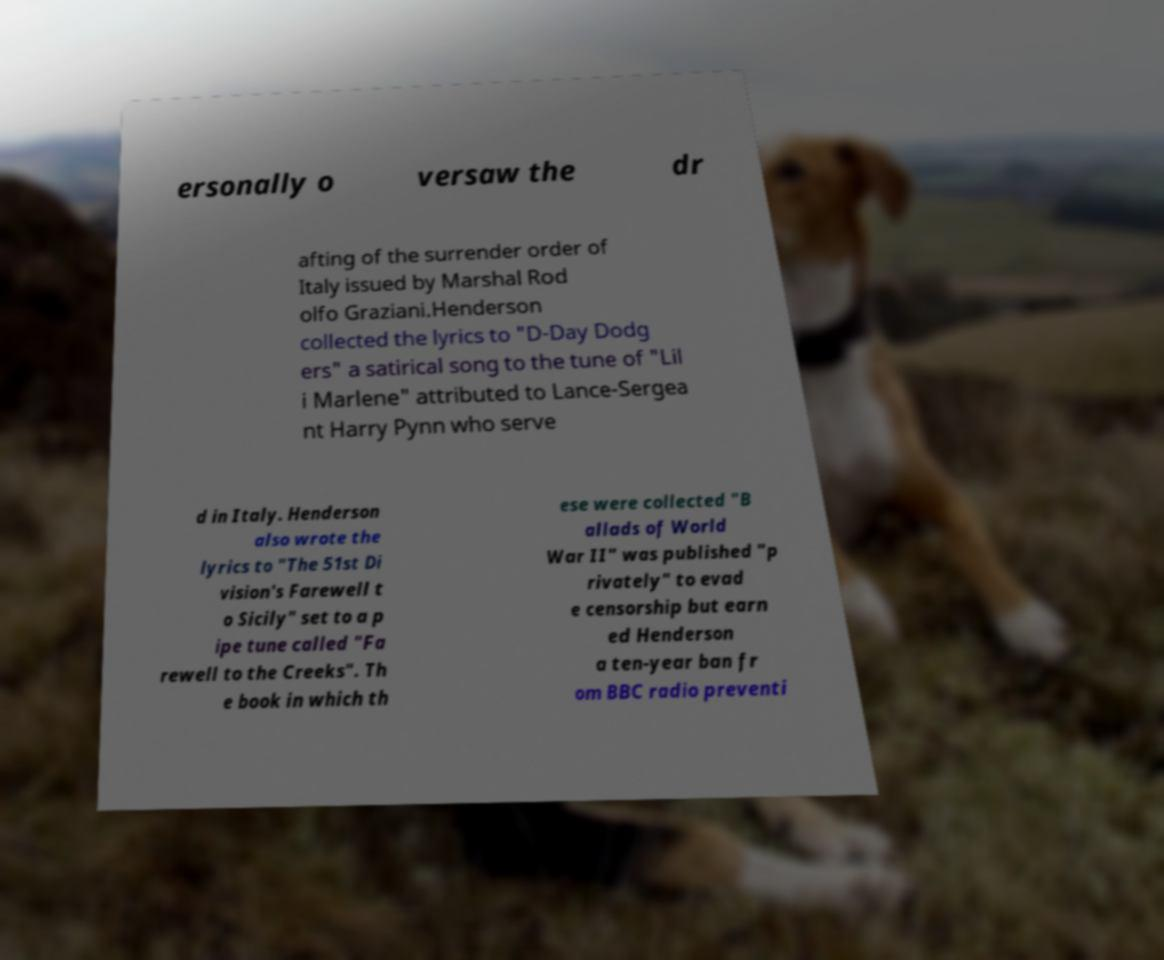Could you assist in decoding the text presented in this image and type it out clearly? ersonally o versaw the dr afting of the surrender order of Italy issued by Marshal Rod olfo Graziani.Henderson collected the lyrics to "D-Day Dodg ers" a satirical song to the tune of "Lil i Marlene" attributed to Lance-Sergea nt Harry Pynn who serve d in Italy. Henderson also wrote the lyrics to "The 51st Di vision's Farewell t o Sicily" set to a p ipe tune called "Fa rewell to the Creeks". Th e book in which th ese were collected "B allads of World War II" was published "p rivately" to evad e censorship but earn ed Henderson a ten-year ban fr om BBC radio preventi 